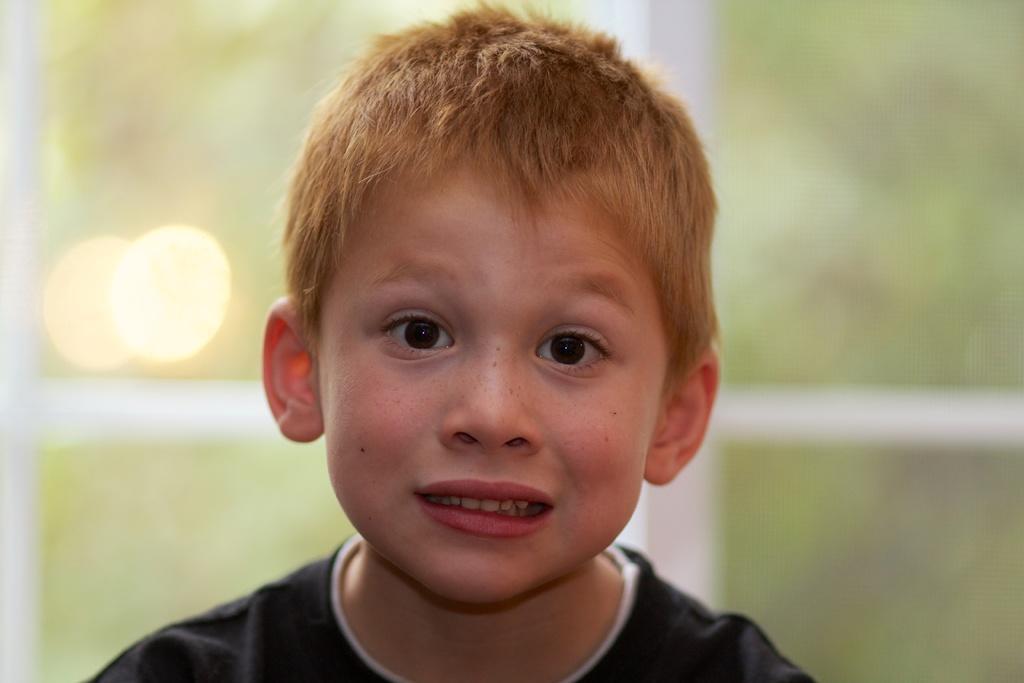In one or two sentences, can you explain what this image depicts? In this image we can see a boy. 